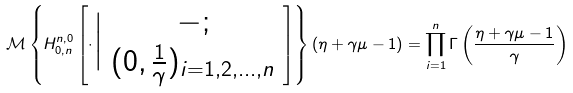<formula> <loc_0><loc_0><loc_500><loc_500>\mathcal { M } \left \{ H ^ { n , 0 } _ { 0 , n } \left [ \cdot \Big | \begin{array} { c } - ; \\ ( 0 , \frac { 1 } { \gamma } ) _ { i = 1 , 2 , \dots , n } \end{array} \right ] \right \} ( \eta + \gamma \mu - 1 ) = \prod _ { i = 1 } ^ { n } \Gamma \left ( \frac { \eta + \gamma \mu - 1 } { \gamma } \right )</formula> 